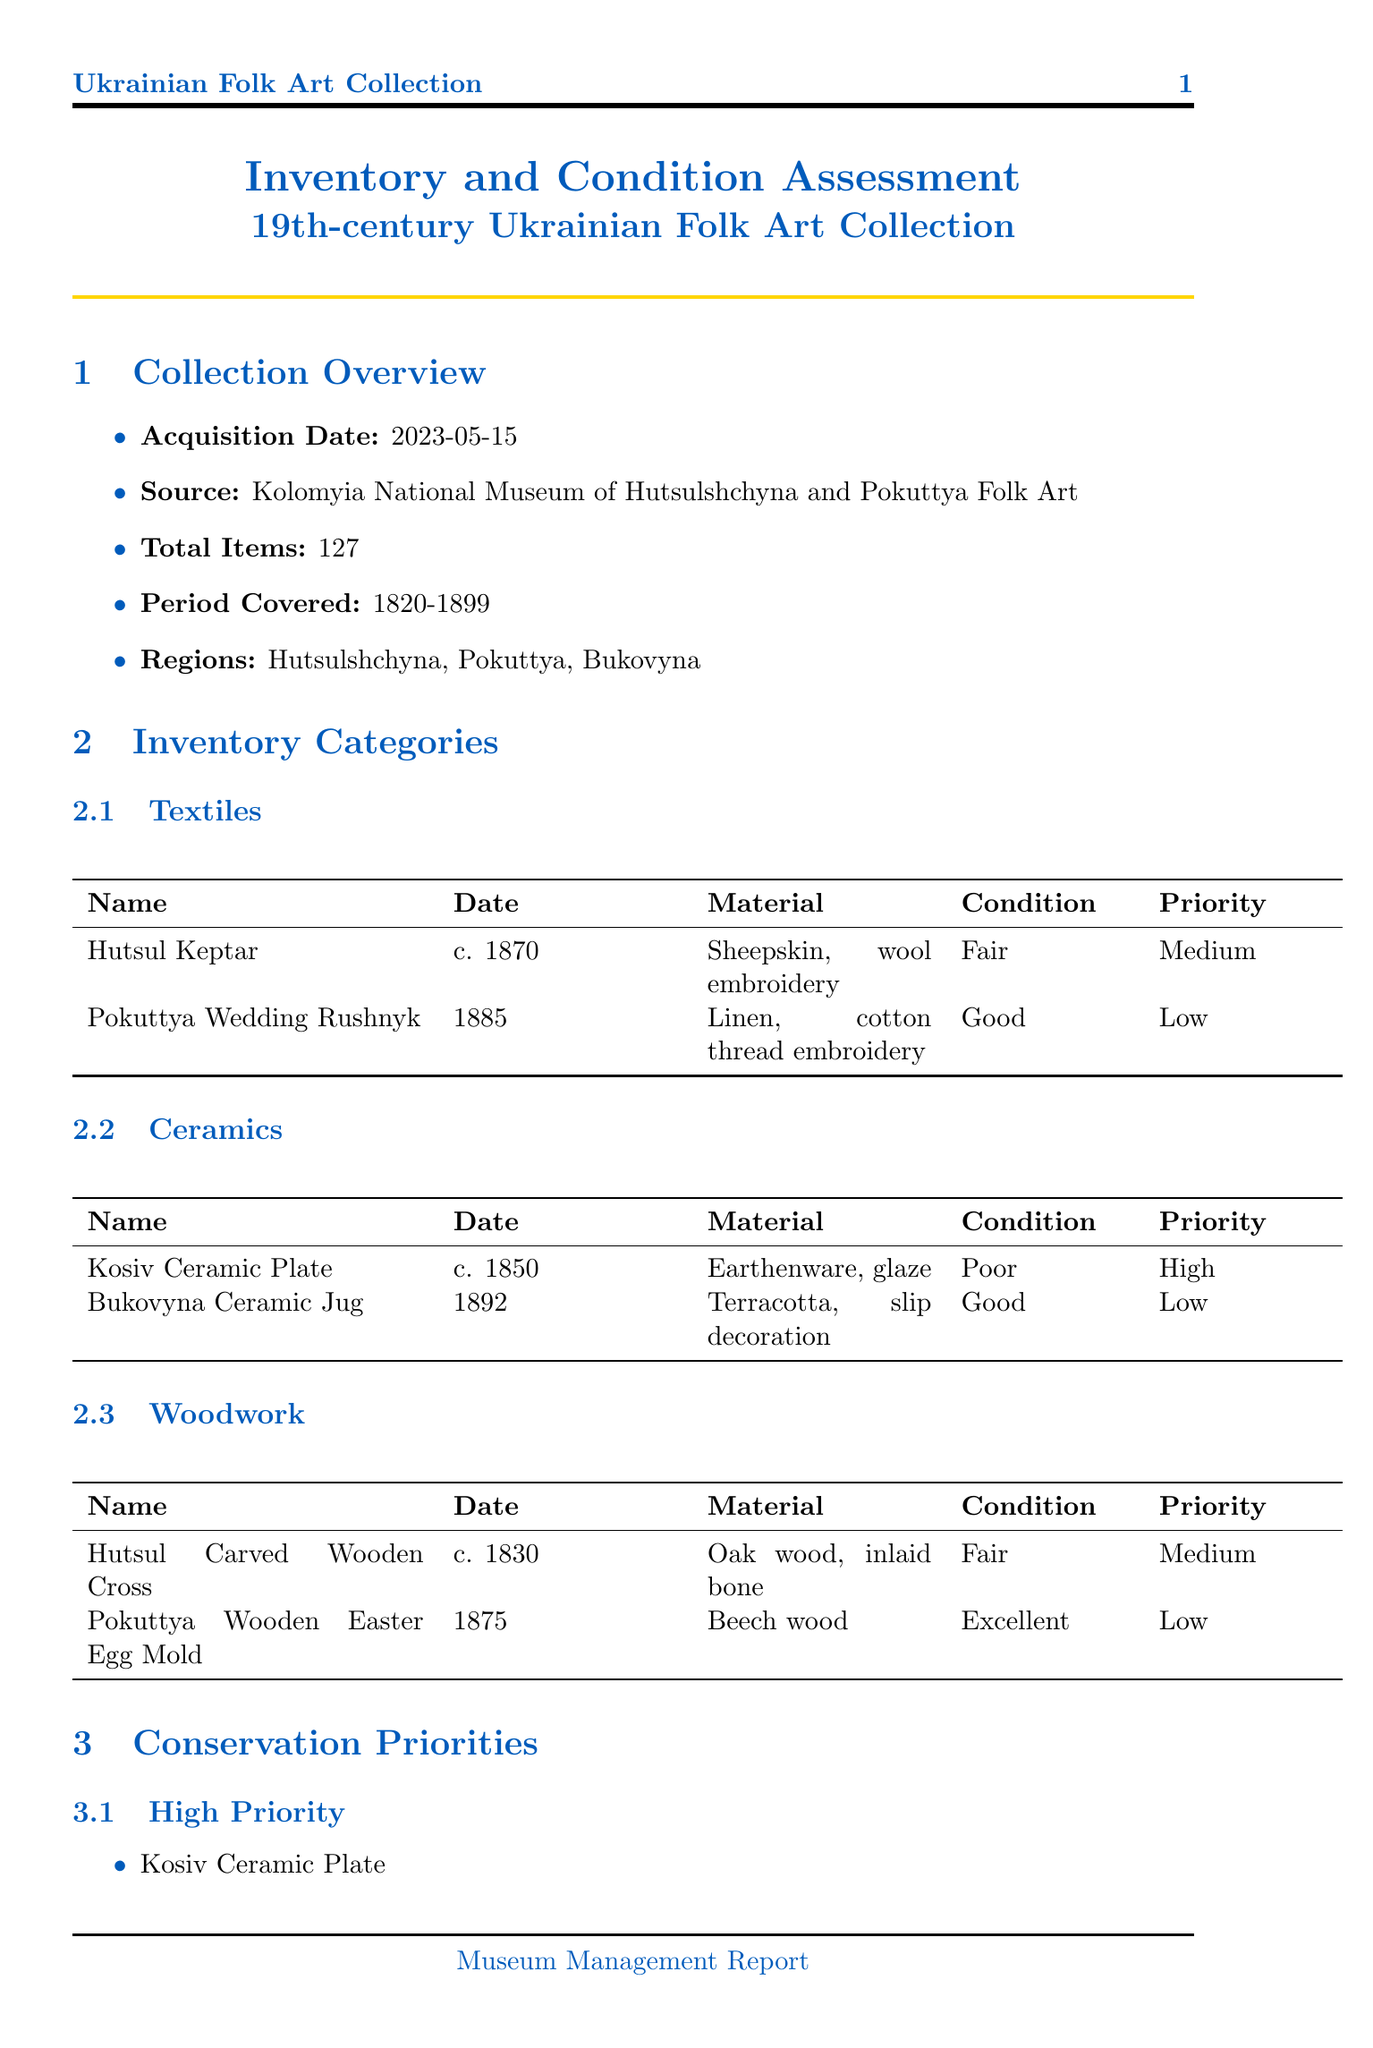What is the acquisition date of the collection? The acquisition date is a specific date mentioned in the document, which is 2023-05-15.
Answer: 2023-05-15 How many total items are in the collection? The total items in the collection are stated directly in the document as 127 items.
Answer: 127 What is the condition of the Kosiv Ceramic Plate? The condition of the Kosiv Ceramic Plate is explicitly provided in the inventory, which indicates it is in a Poor condition.
Answer: Poor Which category does the Bukovyna Ceramic Jug belong to? The document categorizes items and indicates that the Bukovyna Ceramic Jug is listed under Ceramics.
Answer: Ceramics What are the conservation priorities for items in fair condition? The document outlines conservation priorities and indicates items in fair condition have a Medium priority.
Answer: Medium What is the recommended treatment for the Hutsul Keptar? The document specifies that the recommended treatment for the Hutsul Keptar includes leather conditioning and reattachment of loose embroidery.
Answer: Leather conditioning, reattachment of loose embroidery Who conducted the visual inspection of the collection? The document provides details about the inspection and indicates that Olena Shevchenko conducted the visual inspection.
Answer: Olena Shevchenko What is the historical significance of the collection? The document states that the collection represents a crucial period in Ukrainian folk art development, showcasing regional styles and techniques.
Answer: A crucial period in Ukrainian folk art development How many weeks is the estimated duration for the treatment of the Kosiv Ceramic Plate? The treatment duration is mentioned in the document as 4 weeks for the Kosiv Ceramic Plate.
Answer: 4 weeks 